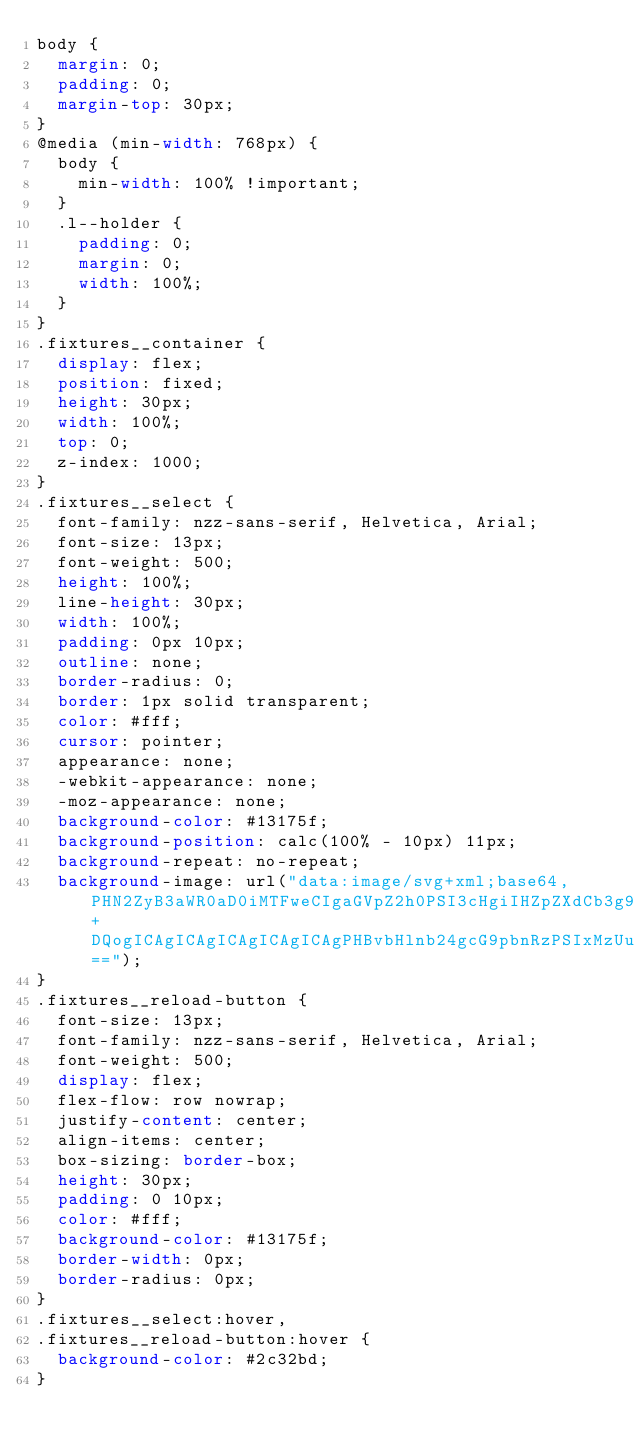<code> <loc_0><loc_0><loc_500><loc_500><_CSS_>body {
  margin: 0;
  padding: 0;
  margin-top: 30px;
}
@media (min-width: 768px) {
  body {
    min-width: 100% !important;
  }
  .l--holder {
    padding: 0;
    margin: 0;
    width: 100%;
  }
}
.fixtures__container {
  display: flex;
  position: fixed;
  height: 30px;
  width: 100%;
  top: 0;
  z-index: 1000;
}
.fixtures__select {
  font-family: nzz-sans-serif, Helvetica, Arial;
  font-size: 13px;
  font-weight: 500;
  height: 100%;
  line-height: 30px;
  width: 100%;
  padding: 0px 10px;
  outline: none;
  border-radius: 0;
  border: 1px solid transparent;
  color: #fff;
  cursor: pointer;
  appearance: none;
  -webkit-appearance: none;
  -moz-appearance: none;
  background-color: #13175f;
  background-position: calc(100% - 10px) 11px;
  background-repeat: no-repeat;
  background-image: url("data:image/svg+xml;base64,PHN2ZyB3aWR0aD0iMTFweCIgaGVpZ2h0PSI3cHgiIHZpZXdCb3g9IjAgMCAxMSA3IiB2ZXJzaW9uPSIxLjEiIHhtbG5zPSJodHRwOi8vd3d3LnczLm9yZy8yMDAwL3N2ZyIgeG1sbnM6eGxpbms9Imh0dHA6Ly93d3cudzMub3JnLzE5OTkveGxpbmsiPg0KICAgIDxnIHN0cm9rZT0ibm9uZSIgc3Ryb2tlLXdpZHRoPSIxIiBmaWxsLXJ1bGU9ImV2ZW5vZGQiPg0KICAgICAgICA8ZyB0cmFuc2Zvcm09InRyYW5zbGF0ZSgtNjAyLCAtMTIyNikiIGZpbGw9IiNGRkYiPg0KICAgICAgICAgICAgPGcgdHJhbnNmb3JtPSJ0cmFuc2xhdGUoNDY4LCAxMjA3KSI+DQogICAgICAgICAgICAgICAgPHBvbHlnb24gcG9pbnRzPSIxMzUuMDU5IDE5IDEzNCAyMC4wNjQgMTM5LjA3NCAyNS4xMjEgMTQ0LjEyMSAyMC4wOTEgMTQzLjA2MyAxOS4wMjggMTM5LjA3NCAyMy4wMDQiPjwvcG9seWdvbj4NCiAgICAgICAgICAgIDwvZz4NCiAgICAgICAgPC9nPg0KICAgIDwvZz4NCjwvc3ZnPg==");
}
.fixtures__reload-button {
  font-size: 13px;
  font-family: nzz-sans-serif, Helvetica, Arial;
  font-weight: 500;
  display: flex;
  flex-flow: row nowrap;
  justify-content: center;
  align-items: center;
  box-sizing: border-box;
  height: 30px;
  padding: 0 10px;
  color: #fff;
  background-color: #13175f;
  border-width: 0px;
  border-radius: 0px;
}
.fixtures__select:hover,
.fixtures__reload-button:hover {
  background-color: #2c32bd;
}
</code> 